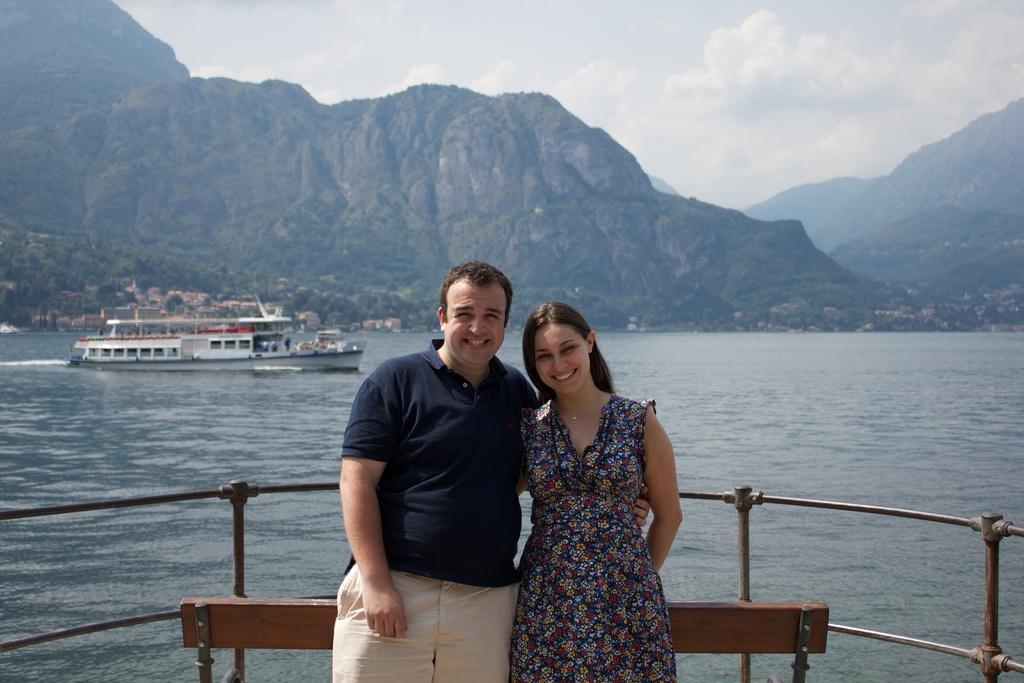How would you summarize this image in a sentence or two? In this image I can see a couple standing. There is a bench and fence behind them. There are ships on the water and there are trees and mountains at the back. There is sky at the top. 